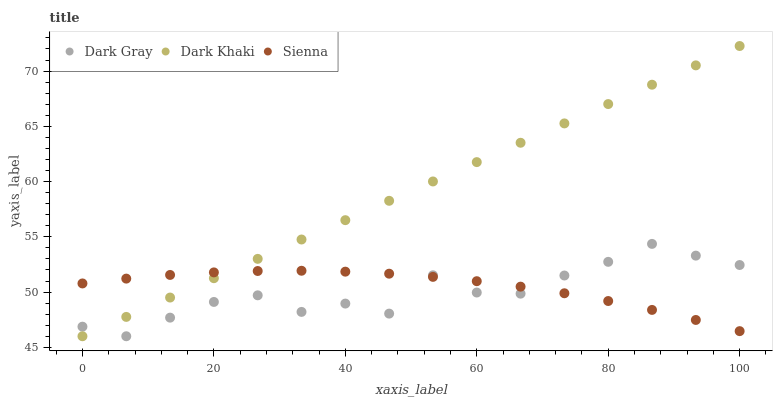Does Dark Gray have the minimum area under the curve?
Answer yes or no. Yes. Does Dark Khaki have the maximum area under the curve?
Answer yes or no. Yes. Does Sienna have the minimum area under the curve?
Answer yes or no. No. Does Sienna have the maximum area under the curve?
Answer yes or no. No. Is Dark Khaki the smoothest?
Answer yes or no. Yes. Is Dark Gray the roughest?
Answer yes or no. Yes. Is Sienna the smoothest?
Answer yes or no. No. Is Sienna the roughest?
Answer yes or no. No. Does Dark Gray have the lowest value?
Answer yes or no. Yes. Does Sienna have the lowest value?
Answer yes or no. No. Does Dark Khaki have the highest value?
Answer yes or no. Yes. Does Sienna have the highest value?
Answer yes or no. No. Does Sienna intersect Dark Gray?
Answer yes or no. Yes. Is Sienna less than Dark Gray?
Answer yes or no. No. Is Sienna greater than Dark Gray?
Answer yes or no. No. 